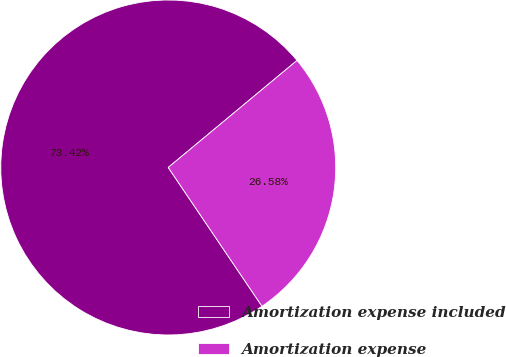Convert chart to OTSL. <chart><loc_0><loc_0><loc_500><loc_500><pie_chart><fcel>Amortization expense included<fcel>Amortization expense<nl><fcel>73.42%<fcel>26.58%<nl></chart> 